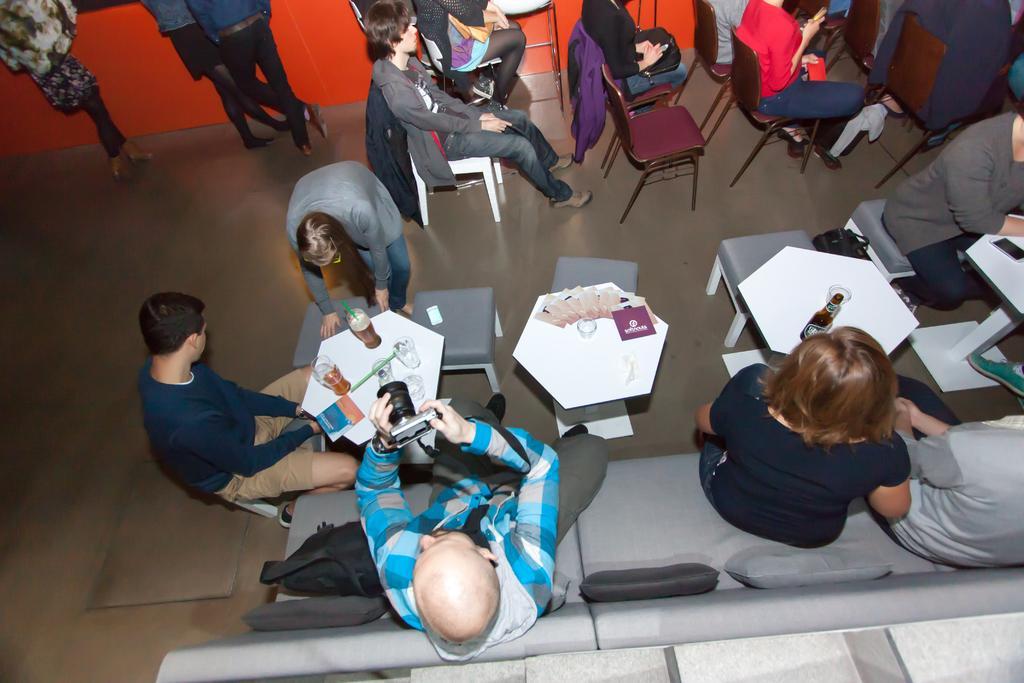Could you give a brief overview of what you see in this image? there is big room there are so many chairs and sofa s some of people they are sitting on the chair and some of people are standing the person is clicking the pictures and some of people they are sitting on the chair. 